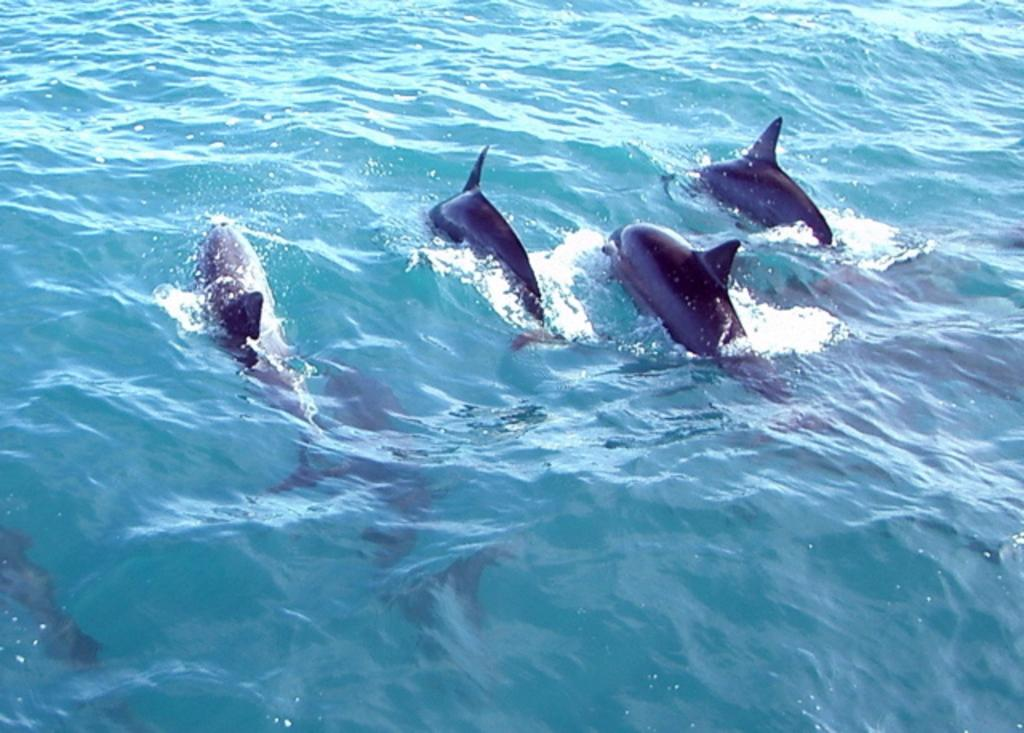What type of animals can be seen in the image? There are fishes in the image. What is the primary element in which the fishes are situated? The fishes are in water. What type of wing can be seen on the fishes in the image? There are no wings present on the fishes in the image, as they are aquatic animals. 